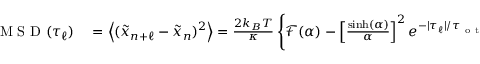Convert formula to latex. <formula><loc_0><loc_0><loc_500><loc_500>\begin{array} { r l } { M S D ( \tau _ { \ell } ) } & = \left \langle ( \tilde { x } _ { n + \ell } - \tilde { x } _ { n } ) ^ { 2 } \right \rangle = \frac { 2 k _ { B } T } { \kappa } \left \{ \mathcal { F } ( \alpha ) - \left [ \frac { \sinh ( \alpha ) } { \alpha } \right ] ^ { 2 } e ^ { - | \tau _ { \ell } | / \tau _ { o t } } \right \} \, . } \end{array}</formula> 